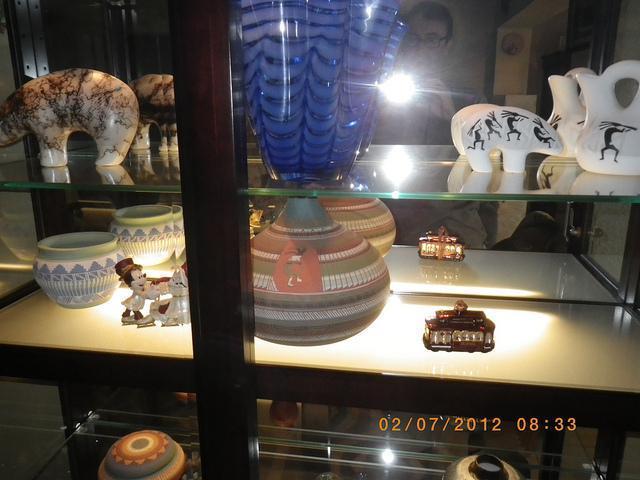How many vases can you see?
Give a very brief answer. 4. 